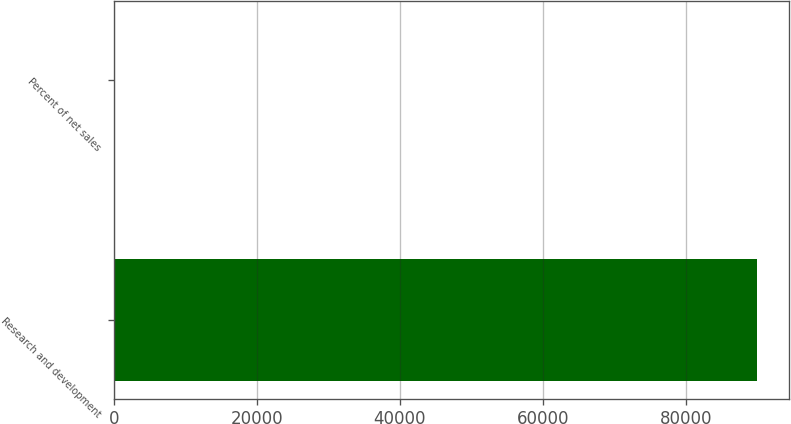Convert chart. <chart><loc_0><loc_0><loc_500><loc_500><bar_chart><fcel>Research and development<fcel>Percent of net sales<nl><fcel>89926<fcel>9.1<nl></chart> 